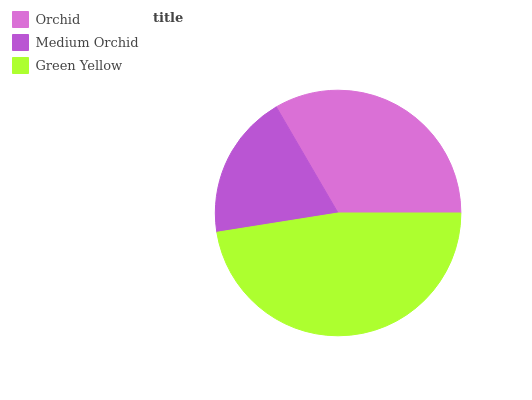Is Medium Orchid the minimum?
Answer yes or no. Yes. Is Green Yellow the maximum?
Answer yes or no. Yes. Is Green Yellow the minimum?
Answer yes or no. No. Is Medium Orchid the maximum?
Answer yes or no. No. Is Green Yellow greater than Medium Orchid?
Answer yes or no. Yes. Is Medium Orchid less than Green Yellow?
Answer yes or no. Yes. Is Medium Orchid greater than Green Yellow?
Answer yes or no. No. Is Green Yellow less than Medium Orchid?
Answer yes or no. No. Is Orchid the high median?
Answer yes or no. Yes. Is Orchid the low median?
Answer yes or no. Yes. Is Medium Orchid the high median?
Answer yes or no. No. Is Green Yellow the low median?
Answer yes or no. No. 